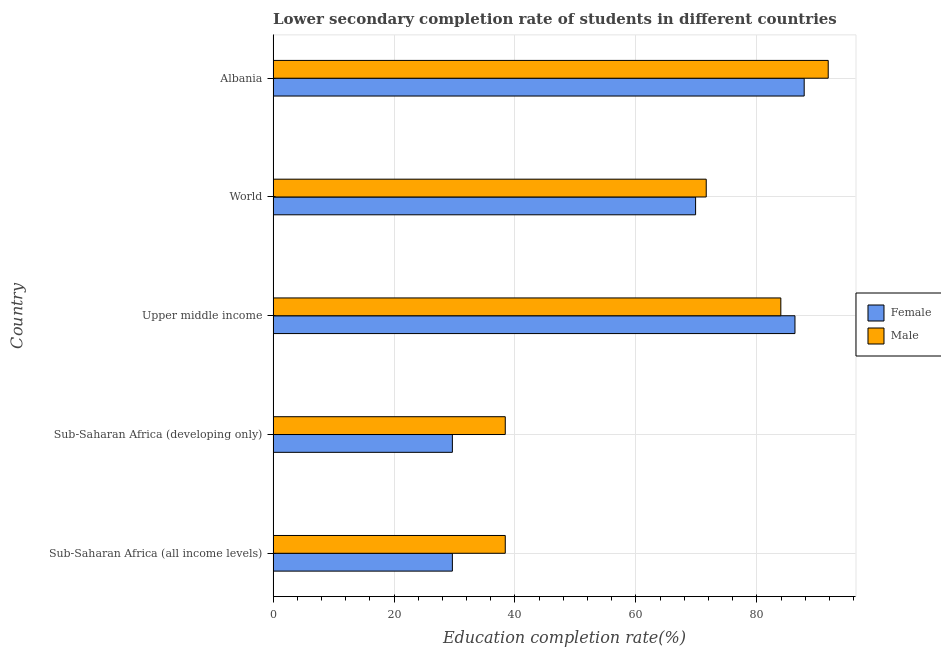How many groups of bars are there?
Provide a succinct answer. 5. How many bars are there on the 5th tick from the bottom?
Provide a succinct answer. 2. What is the label of the 4th group of bars from the top?
Make the answer very short. Sub-Saharan Africa (developing only). What is the education completion rate of male students in World?
Provide a short and direct response. 71.63. Across all countries, what is the maximum education completion rate of female students?
Offer a terse response. 87.83. Across all countries, what is the minimum education completion rate of male students?
Provide a succinct answer. 38.39. In which country was the education completion rate of male students maximum?
Offer a very short reply. Albania. In which country was the education completion rate of male students minimum?
Keep it short and to the point. Sub-Saharan Africa (all income levels). What is the total education completion rate of male students in the graph?
Give a very brief answer. 324.19. What is the difference between the education completion rate of male students in Sub-Saharan Africa (all income levels) and that in World?
Your response must be concise. -33.24. What is the difference between the education completion rate of male students in Sub-Saharan Africa (all income levels) and the education completion rate of female students in Upper middle income?
Make the answer very short. -47.91. What is the average education completion rate of male students per country?
Your answer should be compact. 64.84. What is the difference between the education completion rate of female students and education completion rate of male students in Sub-Saharan Africa (developing only)?
Provide a succinct answer. -8.75. What is the ratio of the education completion rate of female students in Albania to that in Sub-Saharan Africa (all income levels)?
Provide a short and direct response. 2.96. Is the education completion rate of female students in Sub-Saharan Africa (all income levels) less than that in World?
Offer a very short reply. Yes. Is the difference between the education completion rate of male students in Sub-Saharan Africa (all income levels) and World greater than the difference between the education completion rate of female students in Sub-Saharan Africa (all income levels) and World?
Ensure brevity in your answer.  Yes. What is the difference between the highest and the second highest education completion rate of female students?
Offer a very short reply. 1.52. What is the difference between the highest and the lowest education completion rate of female students?
Make the answer very short. 58.18. What does the 2nd bar from the top in Sub-Saharan Africa (all income levels) represents?
Your response must be concise. Female. What does the 2nd bar from the bottom in Albania represents?
Offer a terse response. Male. How many bars are there?
Your answer should be compact. 10. Are all the bars in the graph horizontal?
Keep it short and to the point. Yes. How many countries are there in the graph?
Provide a short and direct response. 5. What is the difference between two consecutive major ticks on the X-axis?
Give a very brief answer. 20. Does the graph contain any zero values?
Offer a terse response. No. Where does the legend appear in the graph?
Offer a terse response. Center right. How are the legend labels stacked?
Provide a succinct answer. Vertical. What is the title of the graph?
Your response must be concise. Lower secondary completion rate of students in different countries. What is the label or title of the X-axis?
Ensure brevity in your answer.  Education completion rate(%). What is the label or title of the Y-axis?
Give a very brief answer. Country. What is the Education completion rate(%) in Female in Sub-Saharan Africa (all income levels)?
Provide a short and direct response. 29.65. What is the Education completion rate(%) of Male in Sub-Saharan Africa (all income levels)?
Your answer should be very brief. 38.39. What is the Education completion rate(%) of Female in Sub-Saharan Africa (developing only)?
Make the answer very short. 29.65. What is the Education completion rate(%) of Male in Sub-Saharan Africa (developing only)?
Keep it short and to the point. 38.39. What is the Education completion rate(%) in Female in Upper middle income?
Make the answer very short. 86.31. What is the Education completion rate(%) in Male in Upper middle income?
Offer a very short reply. 83.97. What is the Education completion rate(%) in Female in World?
Make the answer very short. 69.87. What is the Education completion rate(%) in Male in World?
Give a very brief answer. 71.63. What is the Education completion rate(%) in Female in Albania?
Provide a short and direct response. 87.83. What is the Education completion rate(%) of Male in Albania?
Give a very brief answer. 91.81. Across all countries, what is the maximum Education completion rate(%) of Female?
Give a very brief answer. 87.83. Across all countries, what is the maximum Education completion rate(%) of Male?
Provide a short and direct response. 91.81. Across all countries, what is the minimum Education completion rate(%) of Female?
Your answer should be compact. 29.65. Across all countries, what is the minimum Education completion rate(%) of Male?
Provide a succinct answer. 38.39. What is the total Education completion rate(%) of Female in the graph?
Offer a very short reply. 303.3. What is the total Education completion rate(%) of Male in the graph?
Make the answer very short. 324.19. What is the difference between the Education completion rate(%) in Male in Sub-Saharan Africa (all income levels) and that in Sub-Saharan Africa (developing only)?
Ensure brevity in your answer.  -0. What is the difference between the Education completion rate(%) in Female in Sub-Saharan Africa (all income levels) and that in Upper middle income?
Provide a succinct answer. -56.66. What is the difference between the Education completion rate(%) in Male in Sub-Saharan Africa (all income levels) and that in Upper middle income?
Keep it short and to the point. -45.57. What is the difference between the Education completion rate(%) in Female in Sub-Saharan Africa (all income levels) and that in World?
Your answer should be compact. -40.22. What is the difference between the Education completion rate(%) in Male in Sub-Saharan Africa (all income levels) and that in World?
Give a very brief answer. -33.24. What is the difference between the Education completion rate(%) in Female in Sub-Saharan Africa (all income levels) and that in Albania?
Your answer should be very brief. -58.18. What is the difference between the Education completion rate(%) of Male in Sub-Saharan Africa (all income levels) and that in Albania?
Provide a short and direct response. -53.41. What is the difference between the Education completion rate(%) of Female in Sub-Saharan Africa (developing only) and that in Upper middle income?
Your response must be concise. -56.66. What is the difference between the Education completion rate(%) of Male in Sub-Saharan Africa (developing only) and that in Upper middle income?
Your answer should be very brief. -45.57. What is the difference between the Education completion rate(%) of Female in Sub-Saharan Africa (developing only) and that in World?
Your answer should be very brief. -40.22. What is the difference between the Education completion rate(%) in Male in Sub-Saharan Africa (developing only) and that in World?
Offer a very short reply. -33.24. What is the difference between the Education completion rate(%) of Female in Sub-Saharan Africa (developing only) and that in Albania?
Give a very brief answer. -58.18. What is the difference between the Education completion rate(%) in Male in Sub-Saharan Africa (developing only) and that in Albania?
Offer a terse response. -53.41. What is the difference between the Education completion rate(%) of Female in Upper middle income and that in World?
Your answer should be compact. 16.44. What is the difference between the Education completion rate(%) in Male in Upper middle income and that in World?
Keep it short and to the point. 12.34. What is the difference between the Education completion rate(%) of Female in Upper middle income and that in Albania?
Your answer should be very brief. -1.52. What is the difference between the Education completion rate(%) of Male in Upper middle income and that in Albania?
Ensure brevity in your answer.  -7.84. What is the difference between the Education completion rate(%) of Female in World and that in Albania?
Give a very brief answer. -17.96. What is the difference between the Education completion rate(%) of Male in World and that in Albania?
Offer a terse response. -20.17. What is the difference between the Education completion rate(%) in Female in Sub-Saharan Africa (all income levels) and the Education completion rate(%) in Male in Sub-Saharan Africa (developing only)?
Keep it short and to the point. -8.75. What is the difference between the Education completion rate(%) in Female in Sub-Saharan Africa (all income levels) and the Education completion rate(%) in Male in Upper middle income?
Offer a terse response. -54.32. What is the difference between the Education completion rate(%) in Female in Sub-Saharan Africa (all income levels) and the Education completion rate(%) in Male in World?
Provide a short and direct response. -41.98. What is the difference between the Education completion rate(%) of Female in Sub-Saharan Africa (all income levels) and the Education completion rate(%) of Male in Albania?
Offer a terse response. -62.16. What is the difference between the Education completion rate(%) of Female in Sub-Saharan Africa (developing only) and the Education completion rate(%) of Male in Upper middle income?
Offer a terse response. -54.32. What is the difference between the Education completion rate(%) of Female in Sub-Saharan Africa (developing only) and the Education completion rate(%) of Male in World?
Your answer should be very brief. -41.99. What is the difference between the Education completion rate(%) in Female in Sub-Saharan Africa (developing only) and the Education completion rate(%) in Male in Albania?
Offer a terse response. -62.16. What is the difference between the Education completion rate(%) in Female in Upper middle income and the Education completion rate(%) in Male in World?
Keep it short and to the point. 14.67. What is the difference between the Education completion rate(%) in Female in Upper middle income and the Education completion rate(%) in Male in Albania?
Your answer should be compact. -5.5. What is the difference between the Education completion rate(%) of Female in World and the Education completion rate(%) of Male in Albania?
Keep it short and to the point. -21.94. What is the average Education completion rate(%) in Female per country?
Your response must be concise. 60.66. What is the average Education completion rate(%) of Male per country?
Provide a succinct answer. 64.84. What is the difference between the Education completion rate(%) of Female and Education completion rate(%) of Male in Sub-Saharan Africa (all income levels)?
Your answer should be very brief. -8.75. What is the difference between the Education completion rate(%) in Female and Education completion rate(%) in Male in Sub-Saharan Africa (developing only)?
Offer a very short reply. -8.75. What is the difference between the Education completion rate(%) of Female and Education completion rate(%) of Male in Upper middle income?
Your answer should be very brief. 2.34. What is the difference between the Education completion rate(%) in Female and Education completion rate(%) in Male in World?
Keep it short and to the point. -1.76. What is the difference between the Education completion rate(%) in Female and Education completion rate(%) in Male in Albania?
Your answer should be compact. -3.98. What is the ratio of the Education completion rate(%) in Male in Sub-Saharan Africa (all income levels) to that in Sub-Saharan Africa (developing only)?
Make the answer very short. 1. What is the ratio of the Education completion rate(%) in Female in Sub-Saharan Africa (all income levels) to that in Upper middle income?
Your answer should be compact. 0.34. What is the ratio of the Education completion rate(%) in Male in Sub-Saharan Africa (all income levels) to that in Upper middle income?
Offer a terse response. 0.46. What is the ratio of the Education completion rate(%) in Female in Sub-Saharan Africa (all income levels) to that in World?
Keep it short and to the point. 0.42. What is the ratio of the Education completion rate(%) in Male in Sub-Saharan Africa (all income levels) to that in World?
Give a very brief answer. 0.54. What is the ratio of the Education completion rate(%) in Female in Sub-Saharan Africa (all income levels) to that in Albania?
Your answer should be very brief. 0.34. What is the ratio of the Education completion rate(%) in Male in Sub-Saharan Africa (all income levels) to that in Albania?
Your response must be concise. 0.42. What is the ratio of the Education completion rate(%) of Female in Sub-Saharan Africa (developing only) to that in Upper middle income?
Ensure brevity in your answer.  0.34. What is the ratio of the Education completion rate(%) in Male in Sub-Saharan Africa (developing only) to that in Upper middle income?
Your response must be concise. 0.46. What is the ratio of the Education completion rate(%) of Female in Sub-Saharan Africa (developing only) to that in World?
Your answer should be compact. 0.42. What is the ratio of the Education completion rate(%) of Male in Sub-Saharan Africa (developing only) to that in World?
Provide a short and direct response. 0.54. What is the ratio of the Education completion rate(%) in Female in Sub-Saharan Africa (developing only) to that in Albania?
Your response must be concise. 0.34. What is the ratio of the Education completion rate(%) of Male in Sub-Saharan Africa (developing only) to that in Albania?
Provide a succinct answer. 0.42. What is the ratio of the Education completion rate(%) of Female in Upper middle income to that in World?
Keep it short and to the point. 1.24. What is the ratio of the Education completion rate(%) of Male in Upper middle income to that in World?
Provide a succinct answer. 1.17. What is the ratio of the Education completion rate(%) of Female in Upper middle income to that in Albania?
Your answer should be very brief. 0.98. What is the ratio of the Education completion rate(%) of Male in Upper middle income to that in Albania?
Provide a short and direct response. 0.91. What is the ratio of the Education completion rate(%) in Female in World to that in Albania?
Offer a very short reply. 0.8. What is the ratio of the Education completion rate(%) in Male in World to that in Albania?
Keep it short and to the point. 0.78. What is the difference between the highest and the second highest Education completion rate(%) of Female?
Keep it short and to the point. 1.52. What is the difference between the highest and the second highest Education completion rate(%) in Male?
Provide a short and direct response. 7.84. What is the difference between the highest and the lowest Education completion rate(%) of Female?
Your answer should be compact. 58.18. What is the difference between the highest and the lowest Education completion rate(%) of Male?
Give a very brief answer. 53.41. 